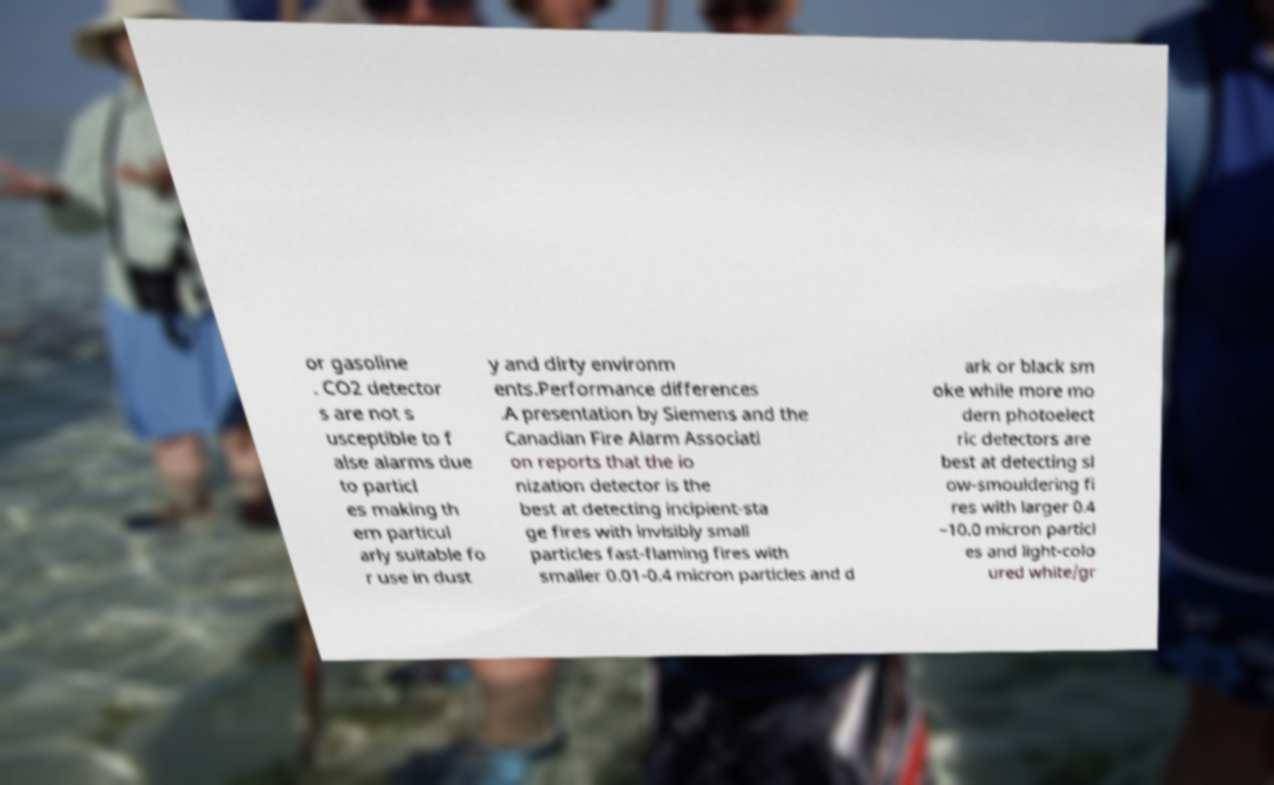Could you assist in decoding the text presented in this image and type it out clearly? or gasoline . CO2 detector s are not s usceptible to f alse alarms due to particl es making th em particul arly suitable fo r use in dust y and dirty environm ents.Performance differences .A presentation by Siemens and the Canadian Fire Alarm Associati on reports that the io nization detector is the best at detecting incipient-sta ge fires with invisibly small particles fast-flaming fires with smaller 0.01-0.4 micron particles and d ark or black sm oke while more mo dern photoelect ric detectors are best at detecting sl ow-smouldering fi res with larger 0.4 –10.0 micron particl es and light-colo ured white/gr 